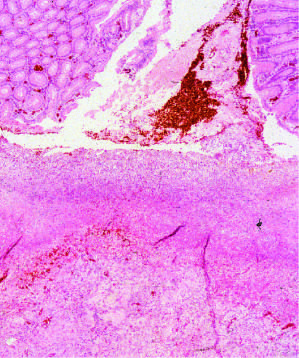s reversible injury composed of granulation tissue overlaid by degraded blood?
Answer the question using a single word or phrase. No 